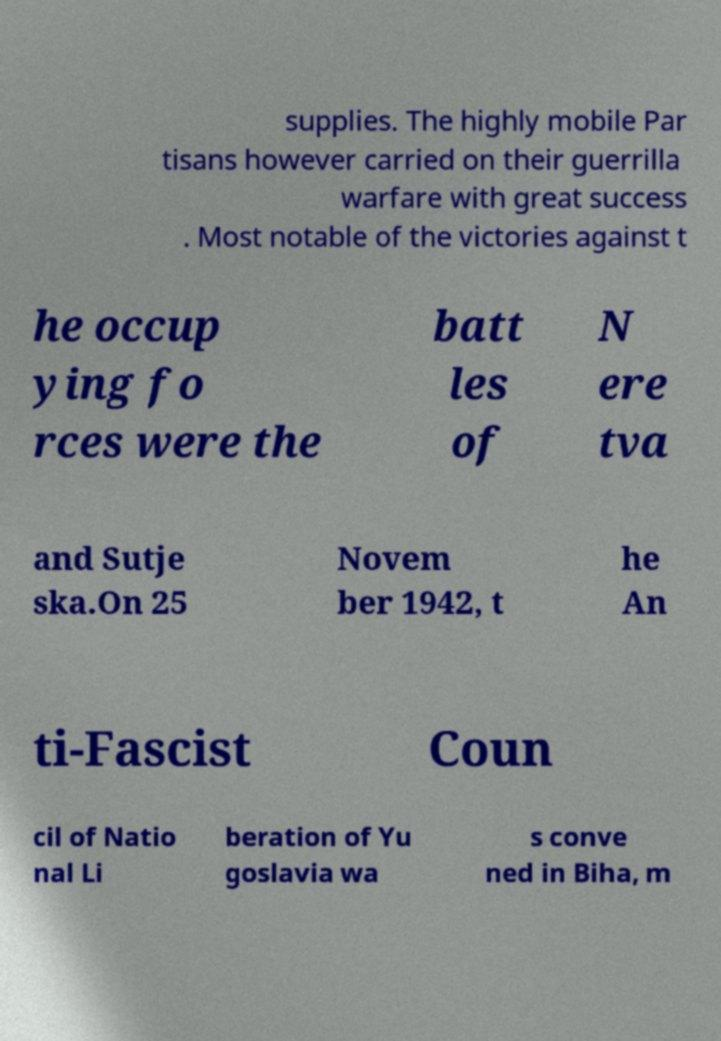Could you extract and type out the text from this image? supplies. The highly mobile Par tisans however carried on their guerrilla warfare with great success . Most notable of the victories against t he occup ying fo rces were the batt les of N ere tva and Sutje ska.On 25 Novem ber 1942, t he An ti-Fascist Coun cil of Natio nal Li beration of Yu goslavia wa s conve ned in Biha, m 